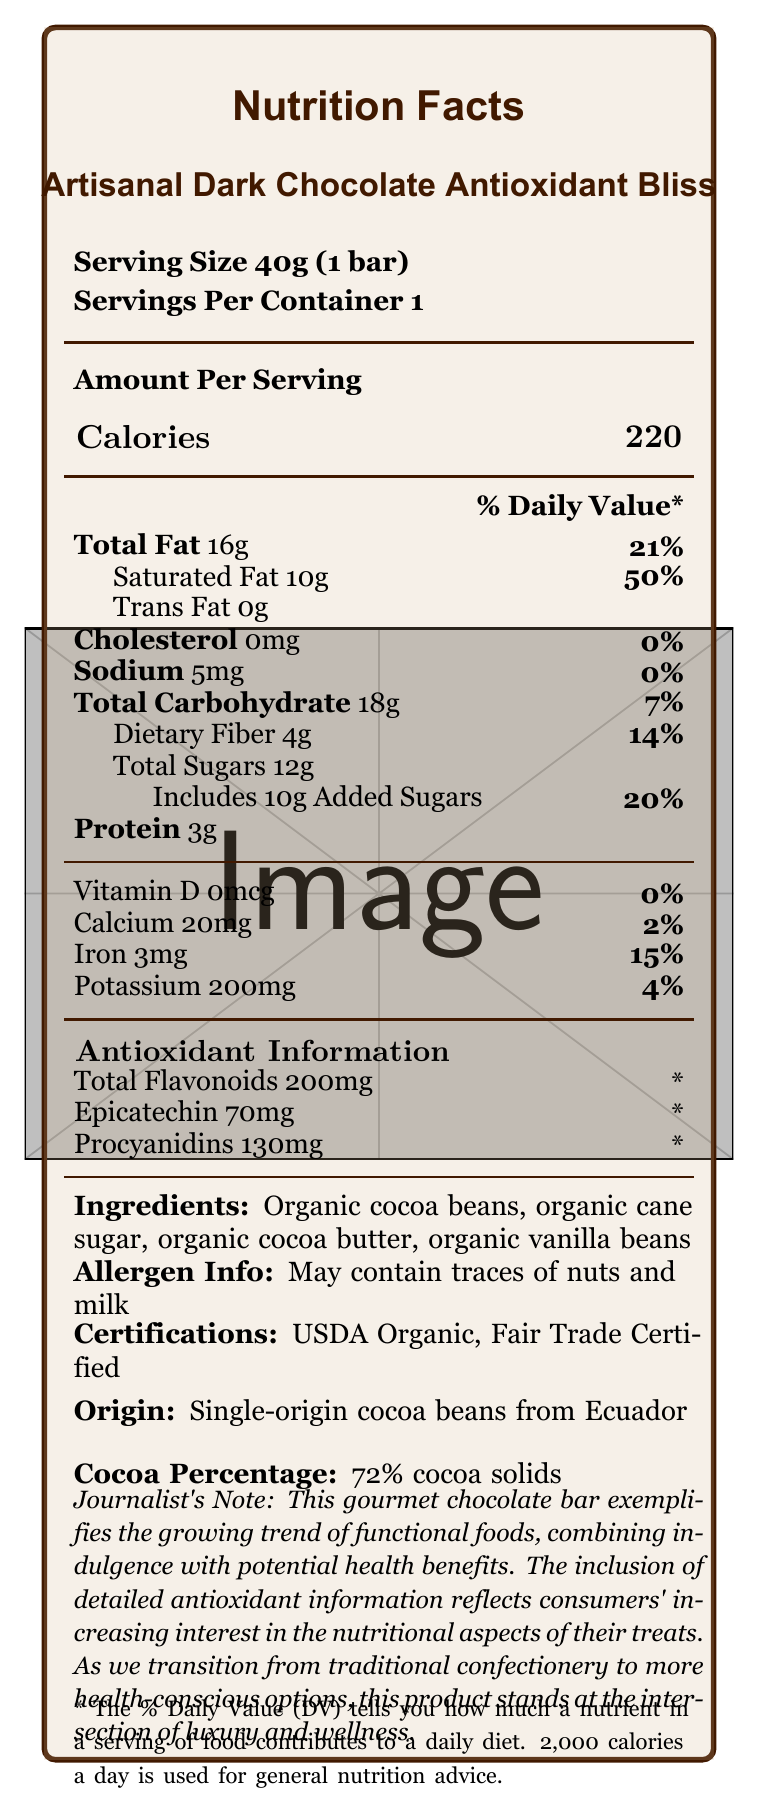what is the serving size? The serving size is explicitly stated as "Serving Size 40g (1 bar)" in the document.
Answer: 40g (1 bar) how many calories are in one serving? The calories per serving are listed as 220 in the "Amount Per Serving" section.
Answer: 220 what is the percentage of daily value for saturated fat? The document states that the daily value for saturated fat is 50%.
Answer: 50% what is the total amount of sugar in one serving? The total sugars in one serving are listed as "Total Sugars 12g".
Answer: 12g how much iron does one serving provide? The iron content per serving is stated as 3mg.
Answer: 3mg are there any added sugars in this chocolate bar? The document specifies "Includes 10g Added Sugars".
Answer: Yes what is the main source of cocoa beans in this chocolate bar? A. Ghana B. Ecuador C. Ivory Coast D. Brazil The origin of the cocoa beans is listed as "Single-origin cocoa beans from Ecuador".
Answer: B. Ecuador how much protein is in one serving? A. 1g B. 2g C. 3g D. 4g The document states that the protein content is 3g.
Answer: C. 3g is this chocolate bar USDA Organic certified? The certifications listed include "USDA Organic".
Answer: Yes what is the total carbohydrate content? The total carbohydrate content for one serving is listed as 18g.
Answer: 18g does this chocolate bar contain any cholesterol? The document lists cholesterol as 0mg.
Answer: No summarize the document in a few sentences. The document provides a detailed overview of the nutritional content, ingredients, and certifications of the Artisanal Dark Chocolate Antioxidant Bliss, emphasizing its antioxidant properties and health-conscious positioning.
Answer: Nutrition Facts of Artisanal Dark Chocolate Antioxidant Bliss: This document outlines the nutritional information for a gourmet dark chocolate bar, highlighting its caloric content, fats, carbohydrates, protein, vitamins, and minerals. It also details the amount of antioxidants present, specifically flavonoids, epicatechin, and procyanidins. The chocolate bar is USDA Organic and Fair Trade Certified, made from single-origin cocoa beans from Ecuador, and contains 72% cocoa solids. The ingredients include organic cocoa beans and other organic ingredients, with a note on potential allergens. what is the percentage of daily value for dietary fiber? The percentage of daily value for dietary fiber is listed as 14%.
Answer: 14% how much sodium is in one serving? A. 5mg B. 10mg C. 15mg D. 20mg The sodium content per serving is listed as 5mg.
Answer: A. 5mg what is the cocoa percentage of this chocolate bar? The document states that the chocolate bar contains 72% cocoa solids.
Answer: 72% cocoa solids is there any information on where to buy this chocolate bar? The document does not provide any information regarding where to purchase the chocolate bar.
Answer: Not enough information does the document list any allergens? It states "May contain traces of nuts and milk" under allergen information.
Answer: Yes how much vitamin D does this chocolate bar contain? The document states that the vitamin D content is 0mcg.
Answer: 0mcg how many total flavonoids are in one serving? The antioxidant information lists total flavonoids as 200mg.
Answer: 200mg what is the relationship between this chocolate bar and functional foods? The document notes that the inclusion of detailed antioxidant information reflects the increasing interest in the nutritional aspects of treats, positioning this product at the intersection of luxury and wellness.
Answer: This chocolate bar is presented as part of a growing trend towards functional foods, combining indulgence with health benefits through its antioxidant properties. 